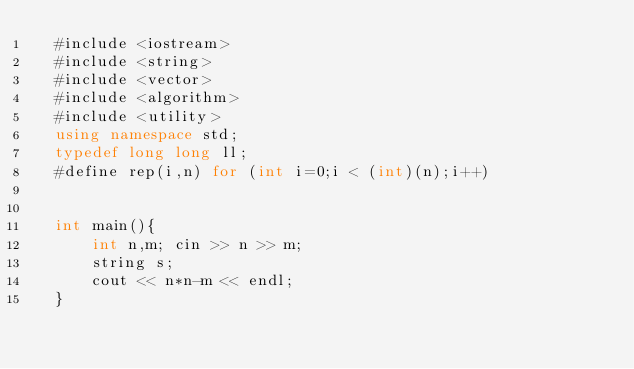<code> <loc_0><loc_0><loc_500><loc_500><_C++_>  #include <iostream>
  #include <string>
  #include <vector>
  #include <algorithm>
  #include <utility>
  using namespace std;
  typedef long long ll;
  #define rep(i,n) for (int i=0;i < (int)(n);i++)
  

  int main(){
      int n,m; cin >> n >> m;
      string s;
      cout << n*n-m << endl;
  }
</code> 